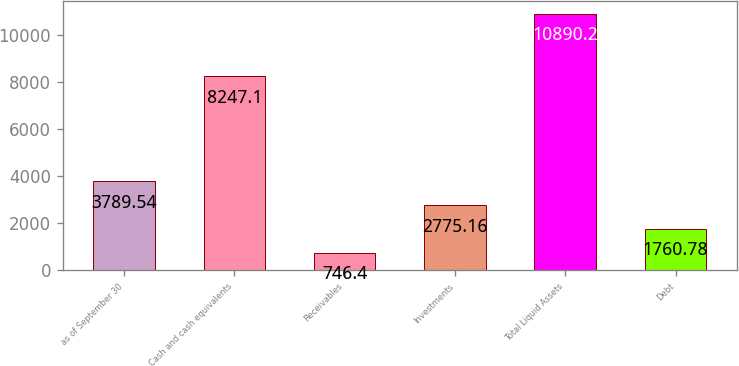Convert chart to OTSL. <chart><loc_0><loc_0><loc_500><loc_500><bar_chart><fcel>as of September 30<fcel>Cash and cash equivalents<fcel>Receivables<fcel>Investments<fcel>Total Liquid Assets<fcel>Debt<nl><fcel>3789.54<fcel>8247.1<fcel>746.4<fcel>2775.16<fcel>10890.2<fcel>1760.78<nl></chart> 